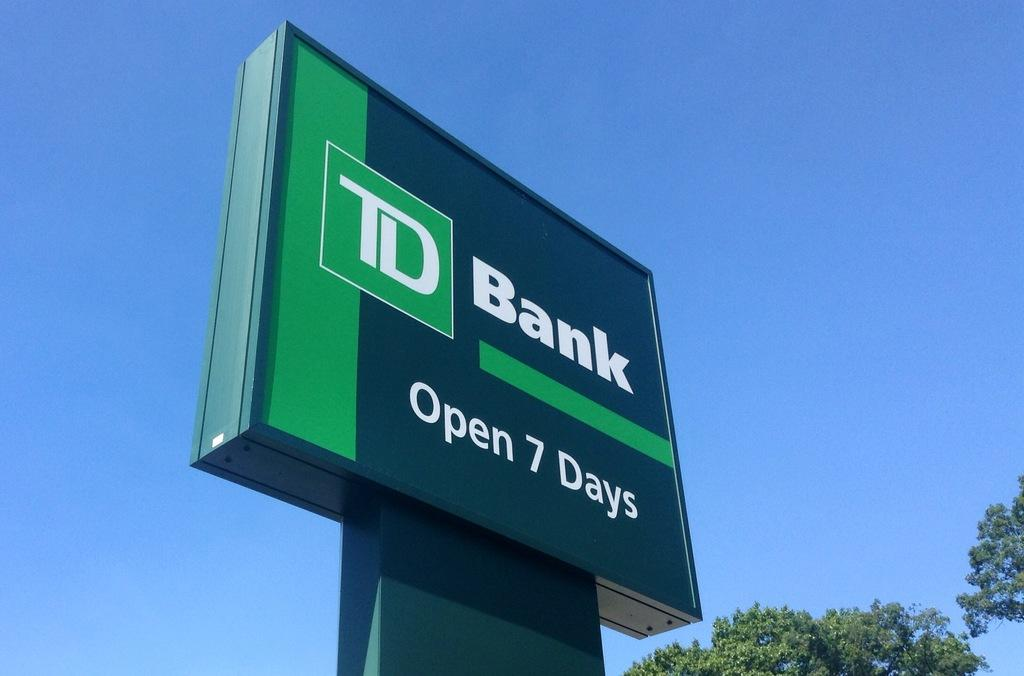<image>
Give a short and clear explanation of the subsequent image. An outside advertisement on a post of TD Bank Open 7 Days. 